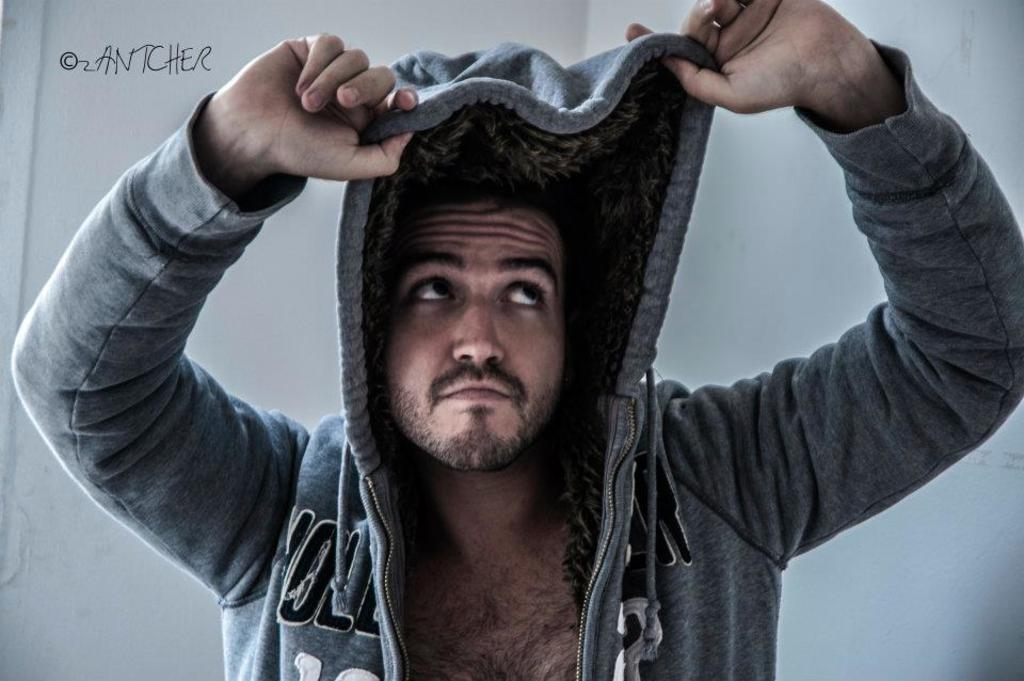What is the main subject of the image? There is a person in the image. What type of clothing is the person wearing? The person is wearing a hoodie. How many snails can be seen crawling on the hoodie in the image? There are no snails visible in the image; the person is wearing a hoodie. What type of doll is sitting on the person's shoulder in the image? There is no doll present in the image; the person is wearing a hoodie. 